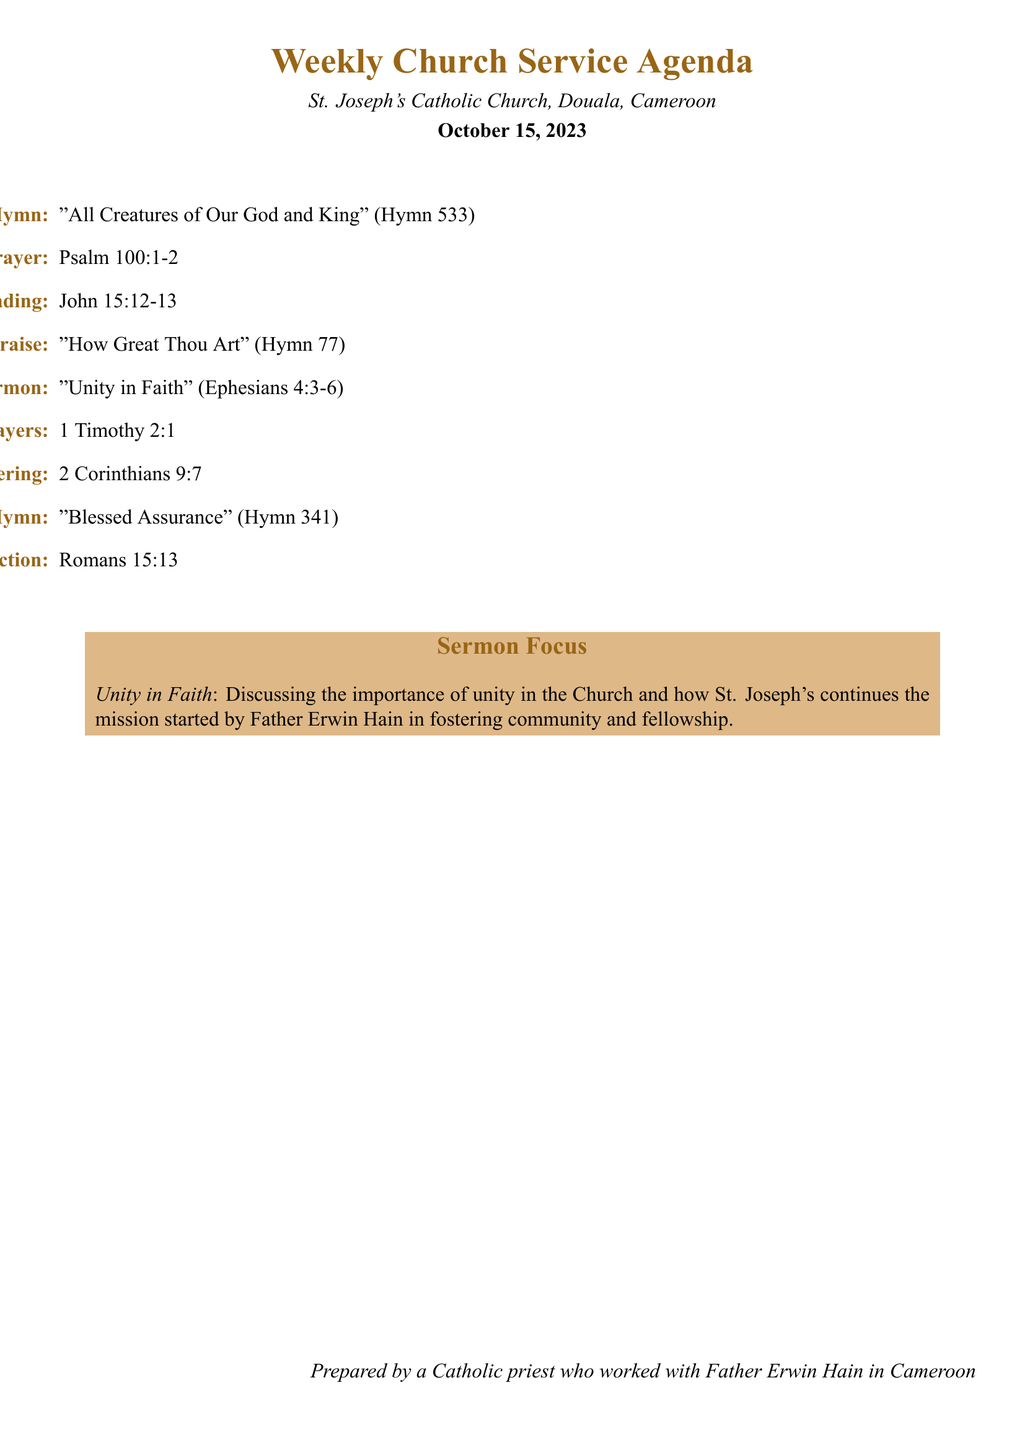What is the opening hymn? The opening hymn listed in the agenda is specified as "All Creatures of Our God and King" (Hymn 533).
Answer: "All Creatures of Our God and King" (Hymn 533) What time does the service begin? The service begins at 8:00 AM, which is noted at the start of the agenda.
Answer: 8:00 AM What scripture is read for the sermon? The scripture identified for the sermon focuses on Ephesians 4:3-6 regarding "Unity in Faith."
Answer: Ephesians 4:3-6 What is the focus of the sermon? The document highlights that the focus of the sermon is on discussing the importance of unity in the Church.
Answer: Unity in Faith What is read during the intercessory prayers? The intercessory prayers reference 1 Timothy 2:1, which is noted in the agenda.
Answer: 1 Timothy 2:1 What is the closing prayer scripture? The closing prayer and benediction cite Romans 15:13 as the reference scripture.
Answer: Romans 15:13 How long is the sermon scheduled to last? The sermon is scheduled from 8:30 AM to 9:00 AM, lasting for 30 minutes.
Answer: 30 minutes Which hymn is sung for the praise? The hymn of praise listed is "How Great Thou Art" (Hymn 77).
Answer: "How Great Thou Art" (Hymn 77) 